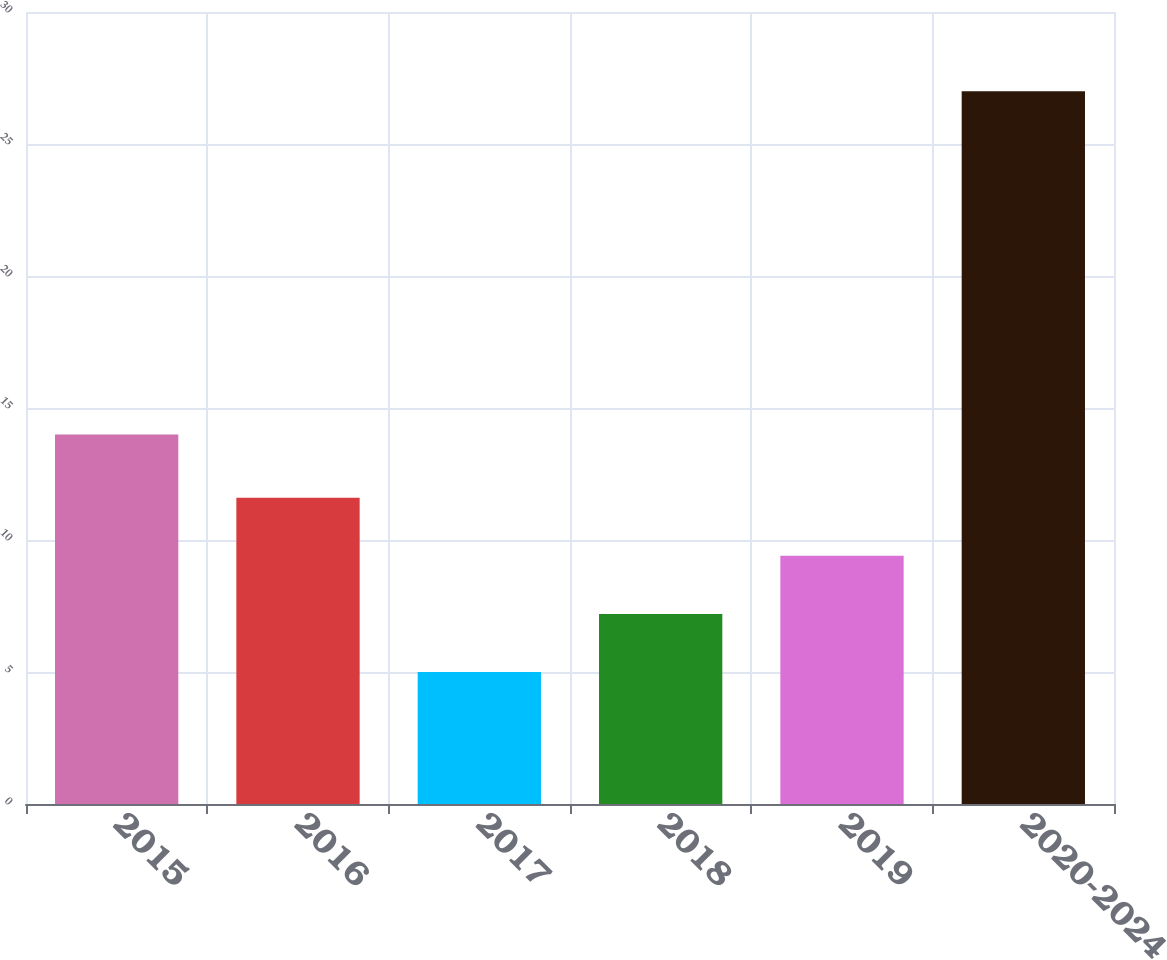Convert chart. <chart><loc_0><loc_0><loc_500><loc_500><bar_chart><fcel>2015<fcel>2016<fcel>2017<fcel>2018<fcel>2019<fcel>2020-2024<nl><fcel>14<fcel>11.6<fcel>5<fcel>7.2<fcel>9.4<fcel>27<nl></chart> 